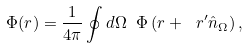Convert formula to latex. <formula><loc_0><loc_0><loc_500><loc_500>\Phi ( { r } ) = \frac { 1 } { 4 \pi } \oint d \Omega \ \Phi \left ( { r } + \ r ^ { \prime } \hat { n } _ { \Omega } \right ) ,</formula> 